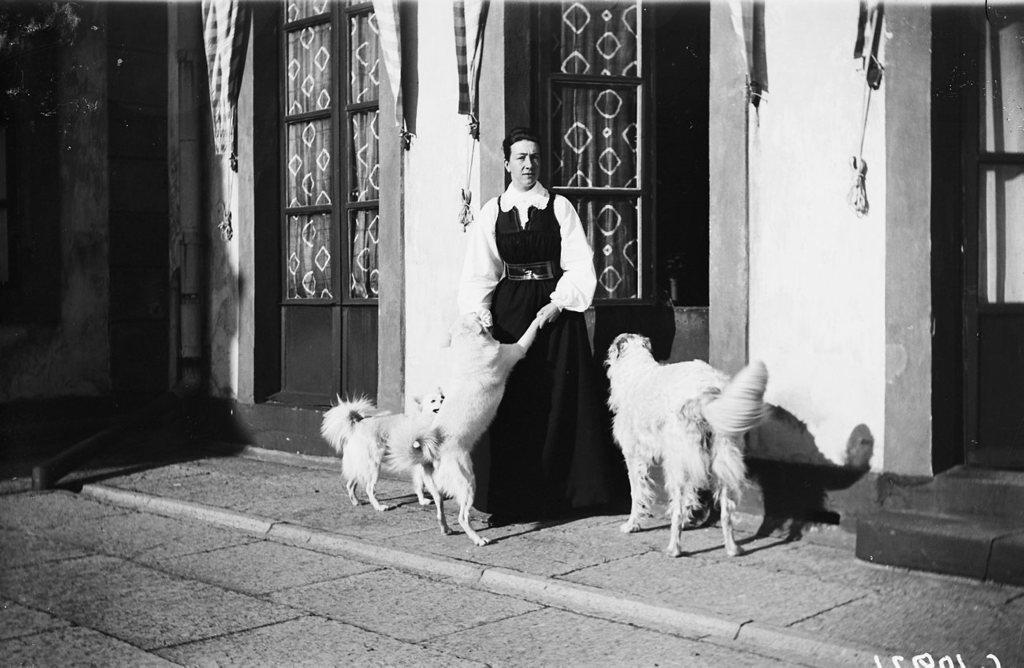Please provide a concise description of this image. The women wearing black and white dress is holding the first two legs of the a dogs and there are two dogs looking at her and in background there is a brown door opened. 